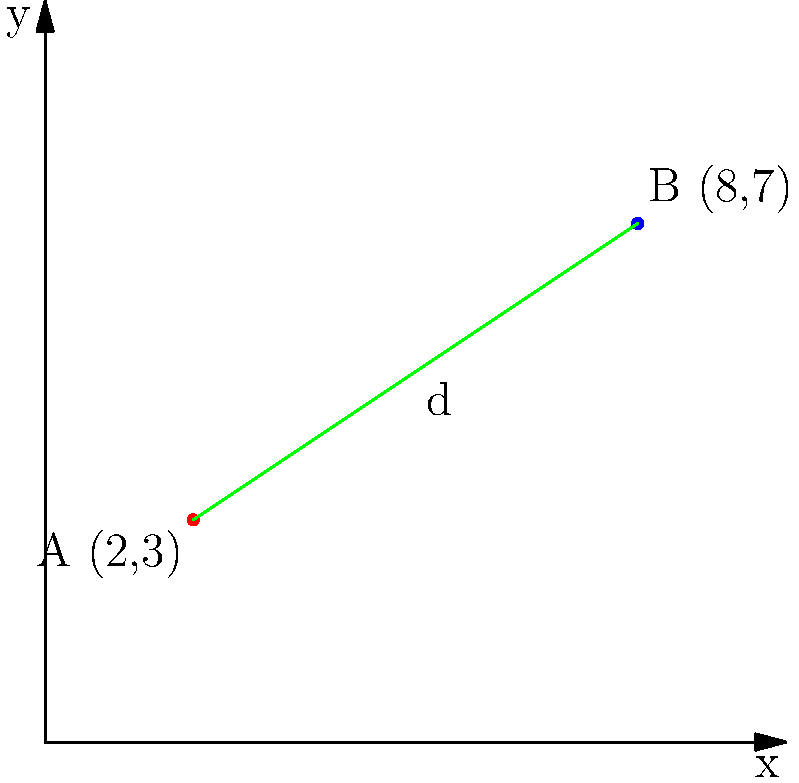In a play about a musician's journey, the protagonist's emotional state is represented on a graph where the x-axis represents time and the y-axis represents emotional intensity. At the beginning of Act I, the character's state is represented by point A (2,3). By the end of Act III, their emotional state has shifted to point B (8,7). Calculate the emotional distance traveled by the protagonist throughout the play, represented by the distance between these two points on the graph. To find the distance between two points on a graph, we can use the distance formula, which is derived from the Pythagorean theorem:

$$ d = \sqrt{(x_2 - x_1)^2 + (y_2 - y_1)^2} $$

Where $(x_1, y_1)$ represents the coordinates of the first point and $(x_2, y_2)$ represents the coordinates of the second point.

Let's plug in our values:
Point A: $(x_1, y_1) = (2, 3)$
Point B: $(x_2, y_2) = (8, 7)$

Now, let's calculate step by step:

1) $d = \sqrt{(8 - 2)^2 + (7 - 3)^2}$

2) $d = \sqrt{6^2 + 4^2}$

3) $d = \sqrt{36 + 16}$

4) $d = \sqrt{52}$

5) $d = 2\sqrt{13}$ (simplifying the square root)

This distance represents the magnitude of emotional change experienced by the protagonist from the beginning of Act I to the end of Act III.
Answer: $2\sqrt{13}$ 